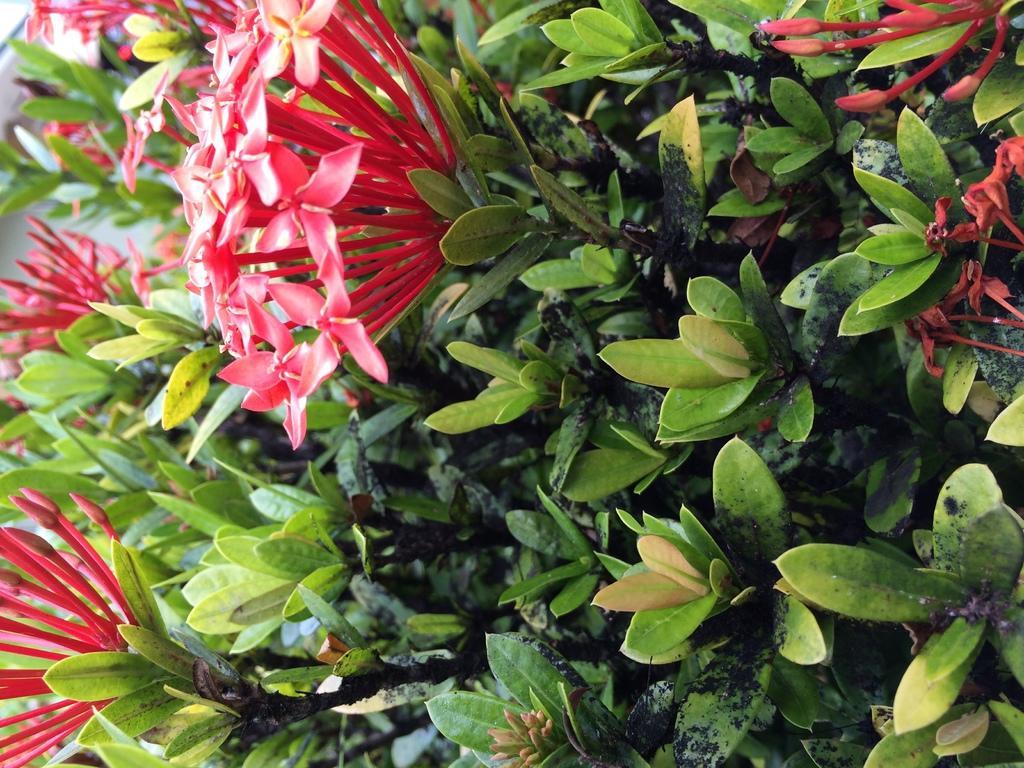Could you give a brief overview of what you see in this image? In the image we can see some flowers and plants. 